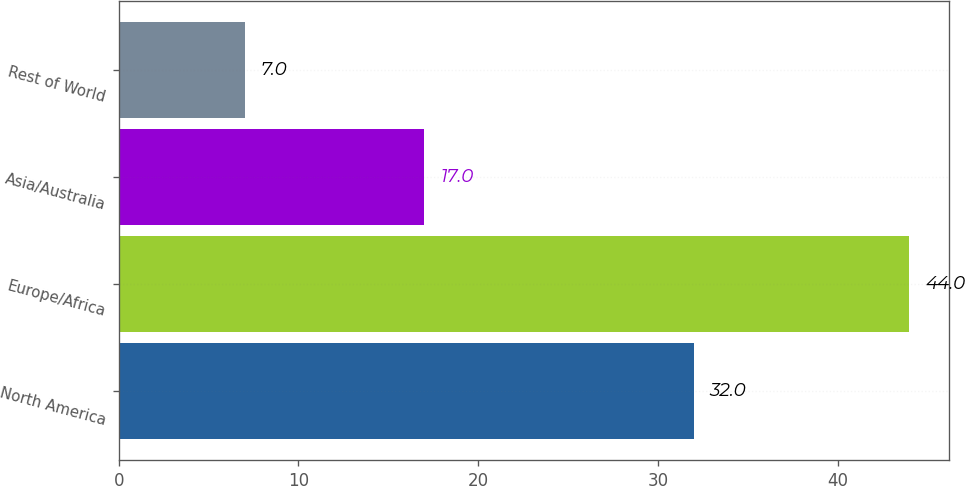Convert chart. <chart><loc_0><loc_0><loc_500><loc_500><bar_chart><fcel>North America<fcel>Europe/Africa<fcel>Asia/Australia<fcel>Rest of World<nl><fcel>32<fcel>44<fcel>17<fcel>7<nl></chart> 